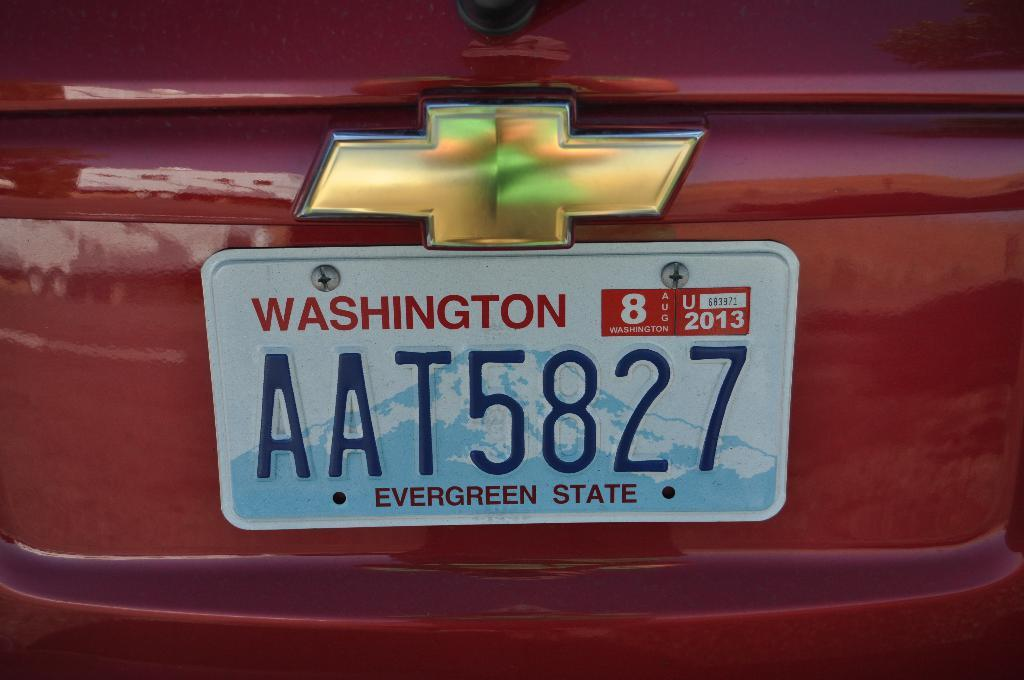<image>
Present a compact description of the photo's key features. A Washington license plate proclaims that it is the Evergreen State. 